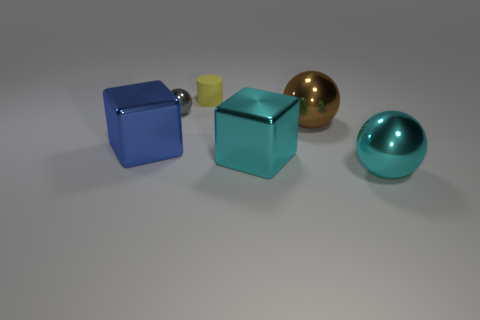Add 4 large red metallic balls. How many objects exist? 10 Subtract all blocks. How many objects are left? 4 Add 3 cyan shiny cubes. How many cyan shiny cubes are left? 4 Add 5 yellow matte things. How many yellow matte things exist? 6 Subtract 1 brown spheres. How many objects are left? 5 Subtract all big cyan spheres. Subtract all gray metal objects. How many objects are left? 4 